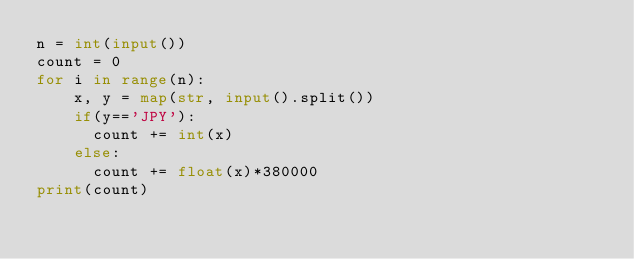Convert code to text. <code><loc_0><loc_0><loc_500><loc_500><_Python_>n = int(input())
count = 0
for i in range(n):
    x, y = map(str, input().split())
    if(y=='JPY'):
      count += int(x)
    else:
      count += float(x)*380000
print(count)   </code> 